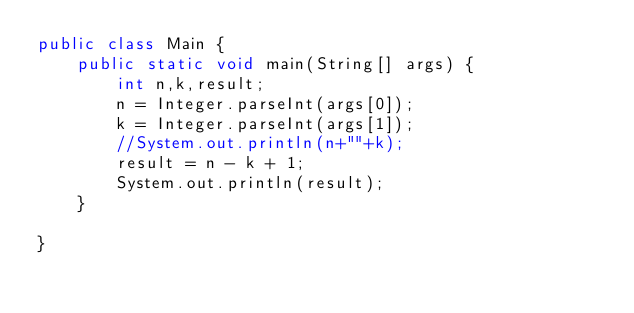<code> <loc_0><loc_0><loc_500><loc_500><_Java_>public class Main {
    public static void main(String[] args) {
        int n,k,result;
        n = Integer.parseInt(args[0]);
        k = Integer.parseInt(args[1]);      
        //System.out.println(n+""+k);
        result = n - k + 1;
        System.out.println(result);
    }

}</code> 